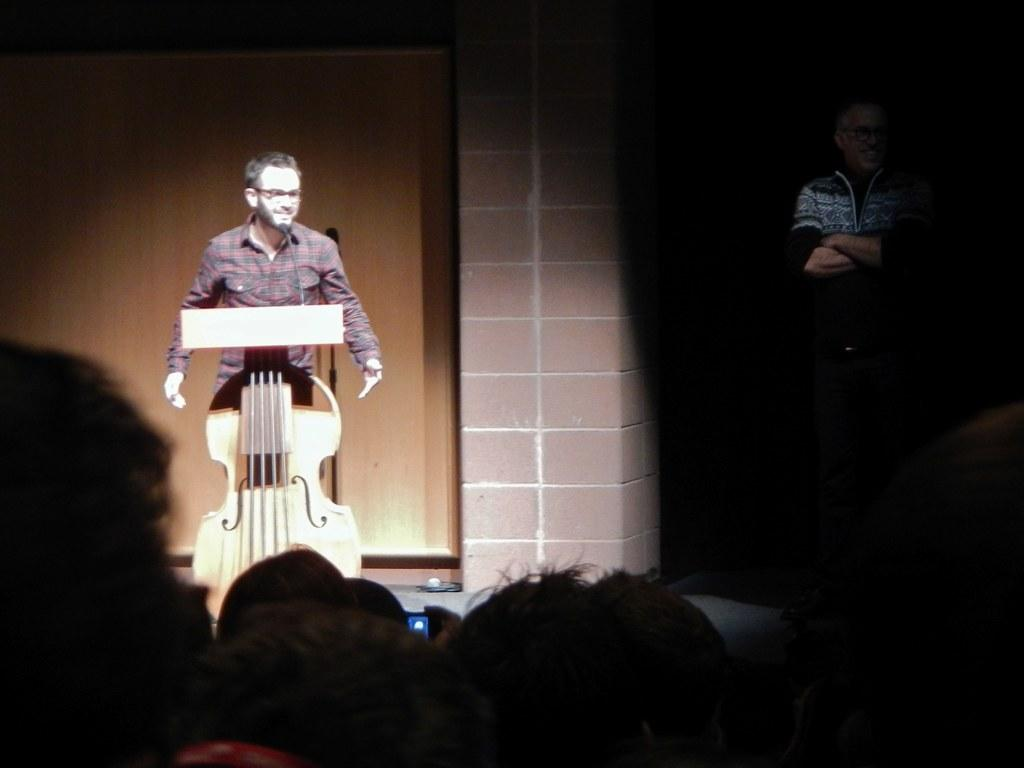How many people are in the image? There are people in the image, but the exact number is not specified. What is the person near the podium doing? The person is standing near a podium. What is on the podium? There is a microphone on the podium. What can be seen in the background of the image? There is a pillar and a wall in the background of the image. What type of rock is being used as a spade in the image? There is no rock or spade present in the image. What country is the image taken in? The country where the image was taken is not mentioned in the facts. 